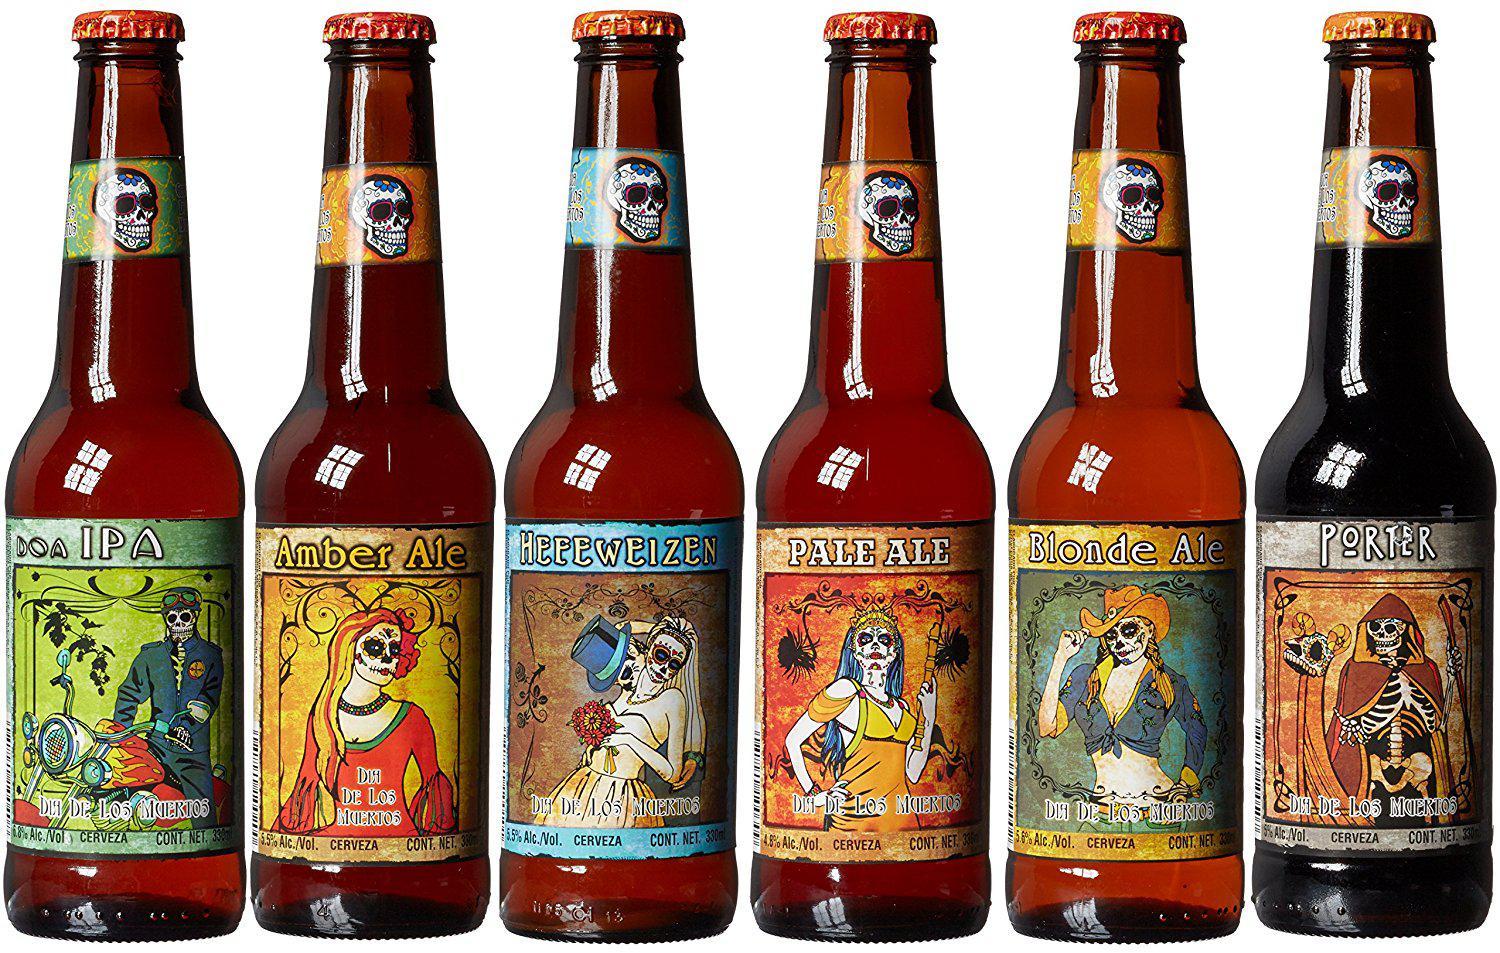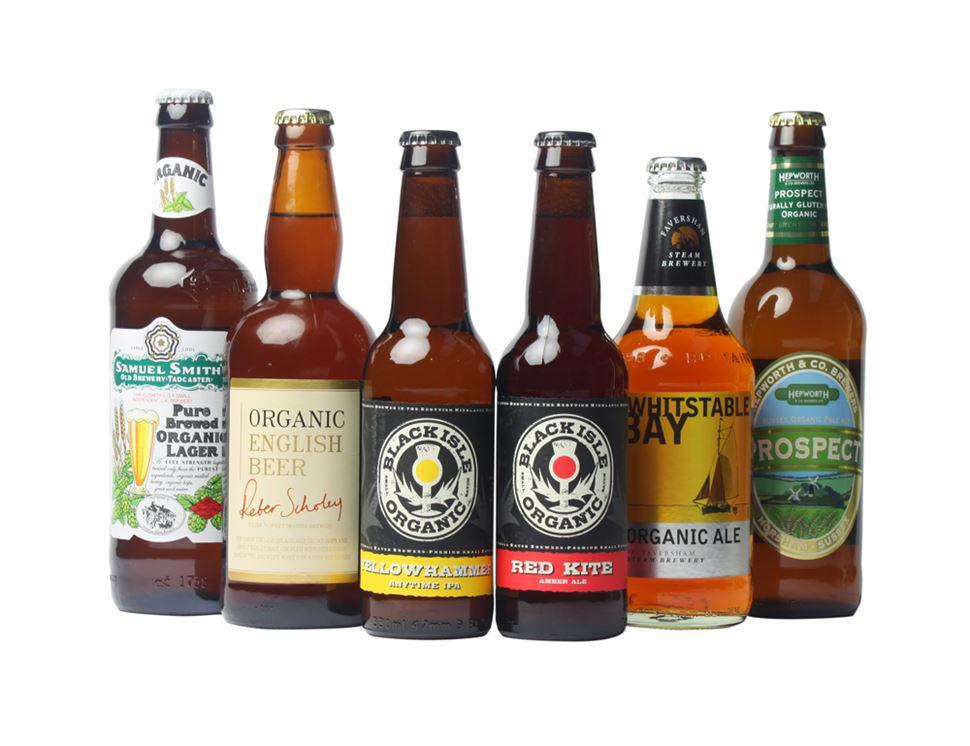The first image is the image on the left, the second image is the image on the right. Evaluate the accuracy of this statement regarding the images: "No bottles have labels or metal openers on top.". Is it true? Answer yes or no. No. The first image is the image on the left, the second image is the image on the right. Assess this claim about the two images: "The bottles are of two colors and none have lables.". Correct or not? Answer yes or no. No. 